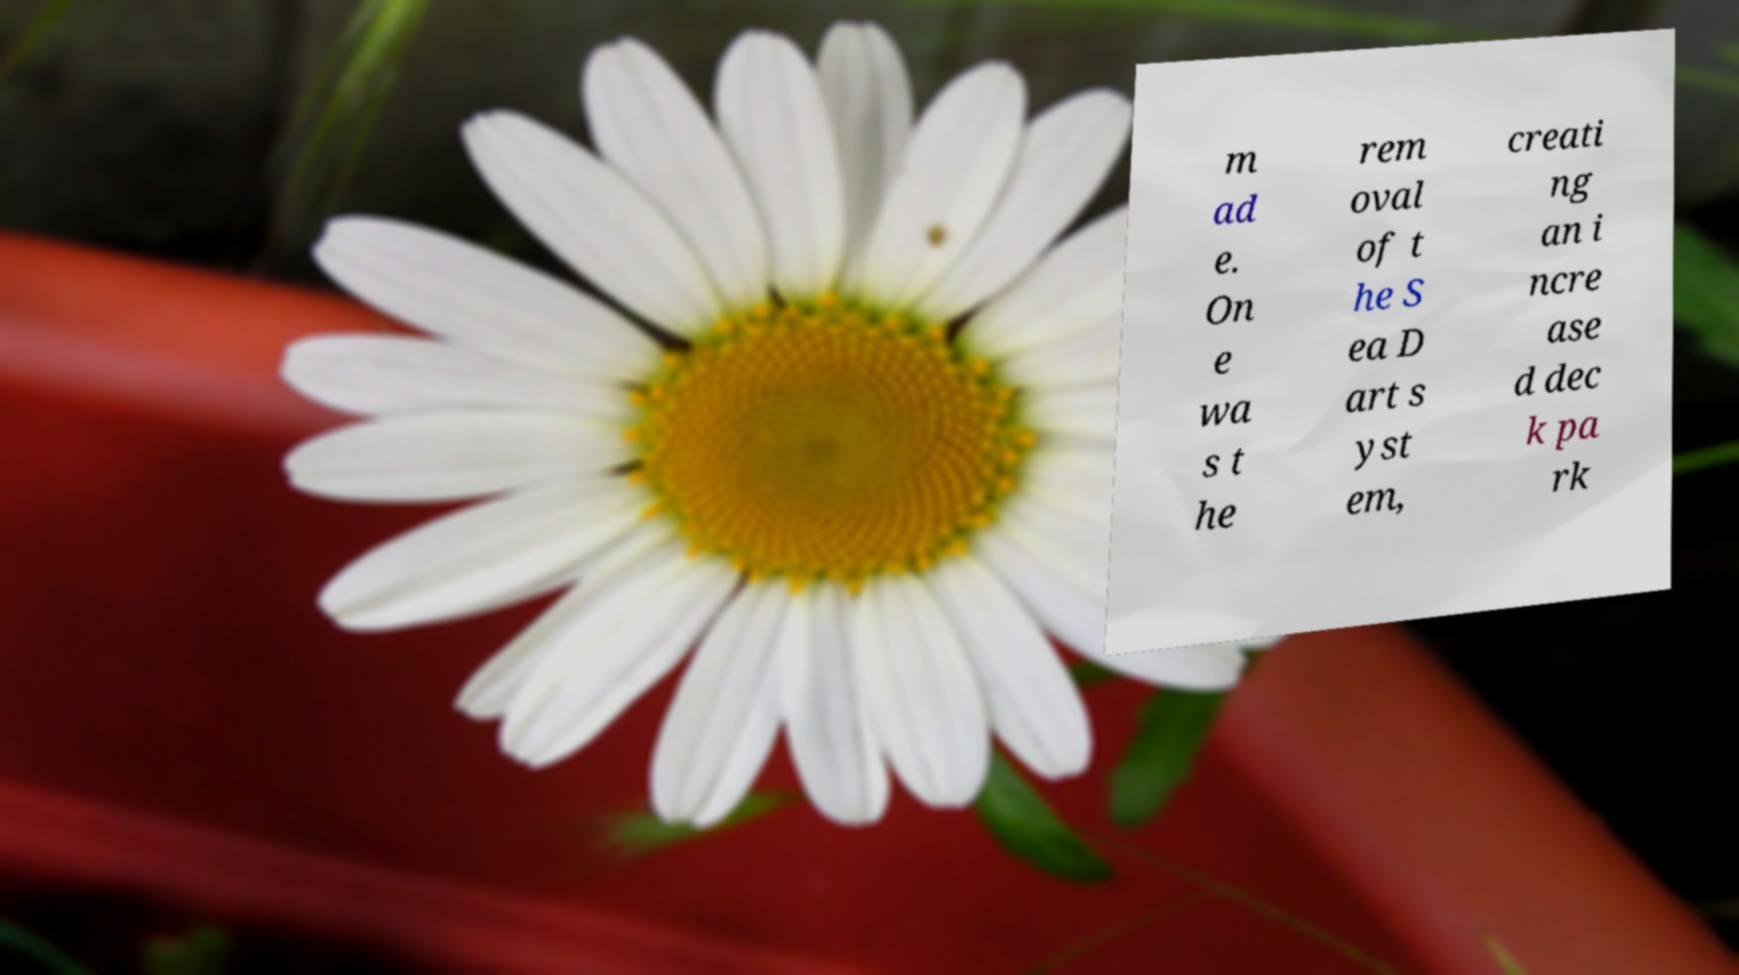Please identify and transcribe the text found in this image. m ad e. On e wa s t he rem oval of t he S ea D art s yst em, creati ng an i ncre ase d dec k pa rk 